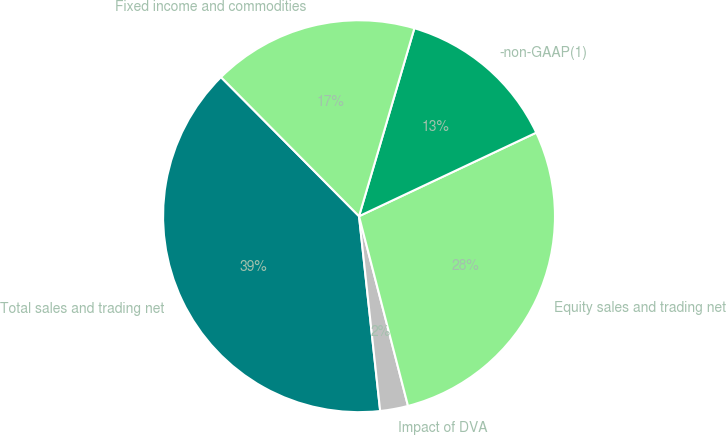Convert chart to OTSL. <chart><loc_0><loc_0><loc_500><loc_500><pie_chart><fcel>Total sales and trading net<fcel>Impact of DVA<fcel>Equity sales and trading net<fcel>-non-GAAP(1)<fcel>Fixed income and commodities<nl><fcel>39.28%<fcel>2.3%<fcel>27.99%<fcel>13.43%<fcel>17.0%<nl></chart> 